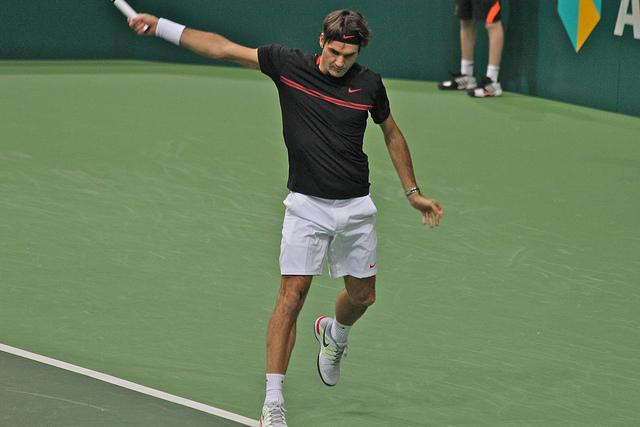What is the man in the foreground wearing on his feet? tennis shoes 